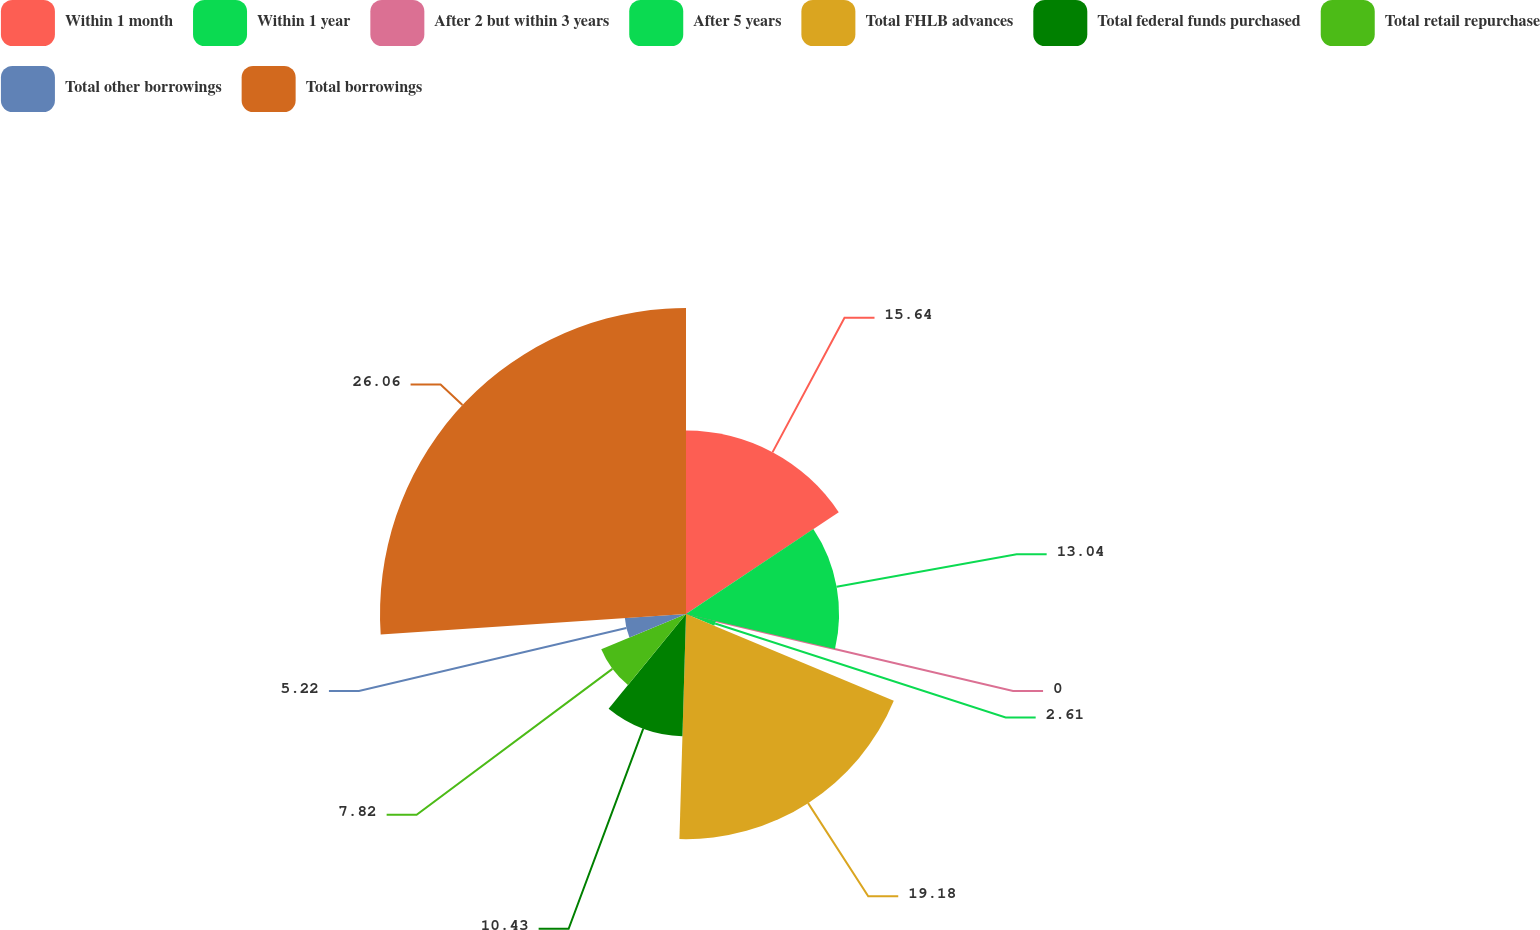Convert chart to OTSL. <chart><loc_0><loc_0><loc_500><loc_500><pie_chart><fcel>Within 1 month<fcel>Within 1 year<fcel>After 2 but within 3 years<fcel>After 5 years<fcel>Total FHLB advances<fcel>Total federal funds purchased<fcel>Total retail repurchase<fcel>Total other borrowings<fcel>Total borrowings<nl><fcel>15.64%<fcel>13.04%<fcel>0.0%<fcel>2.61%<fcel>19.18%<fcel>10.43%<fcel>7.82%<fcel>5.22%<fcel>26.07%<nl></chart> 